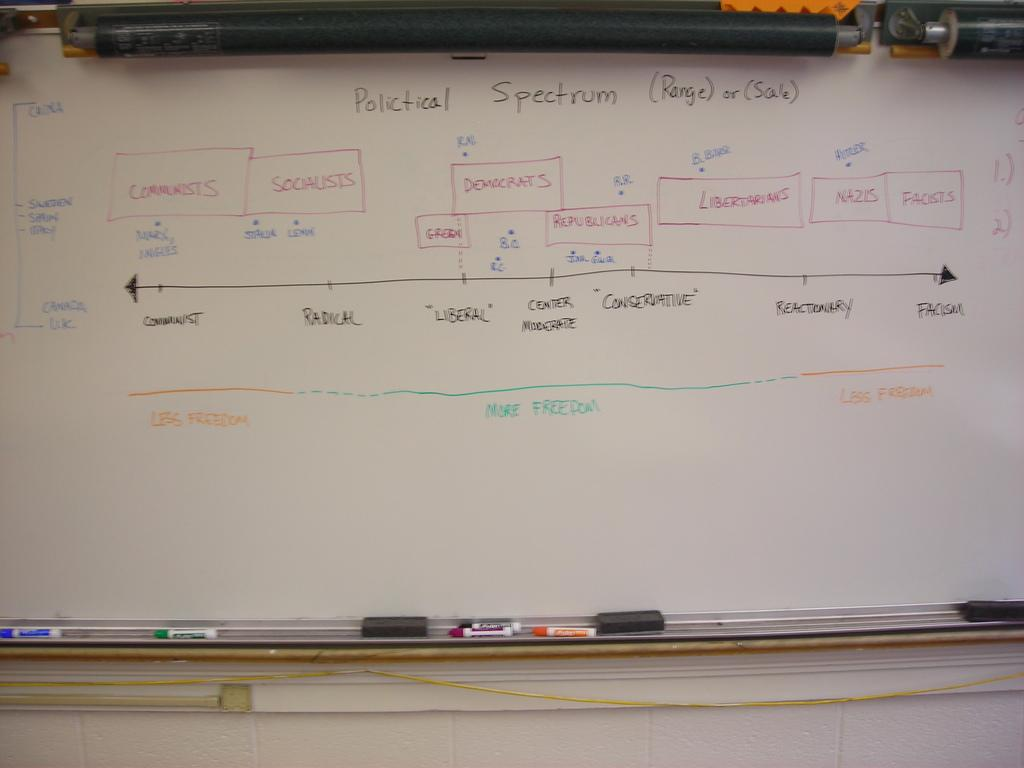Provide a one-sentence caption for the provided image. A chart showing differences the Political Spectrum between facism and communism. 